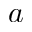<formula> <loc_0><loc_0><loc_500><loc_500>a</formula> 